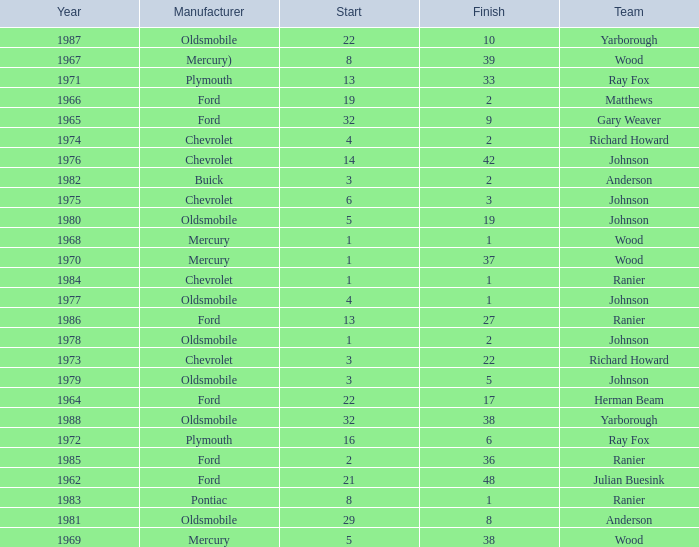What is the smallest finish time for a race where start was less than 3, buick was the manufacturer, and the race was held after 1978? None. 